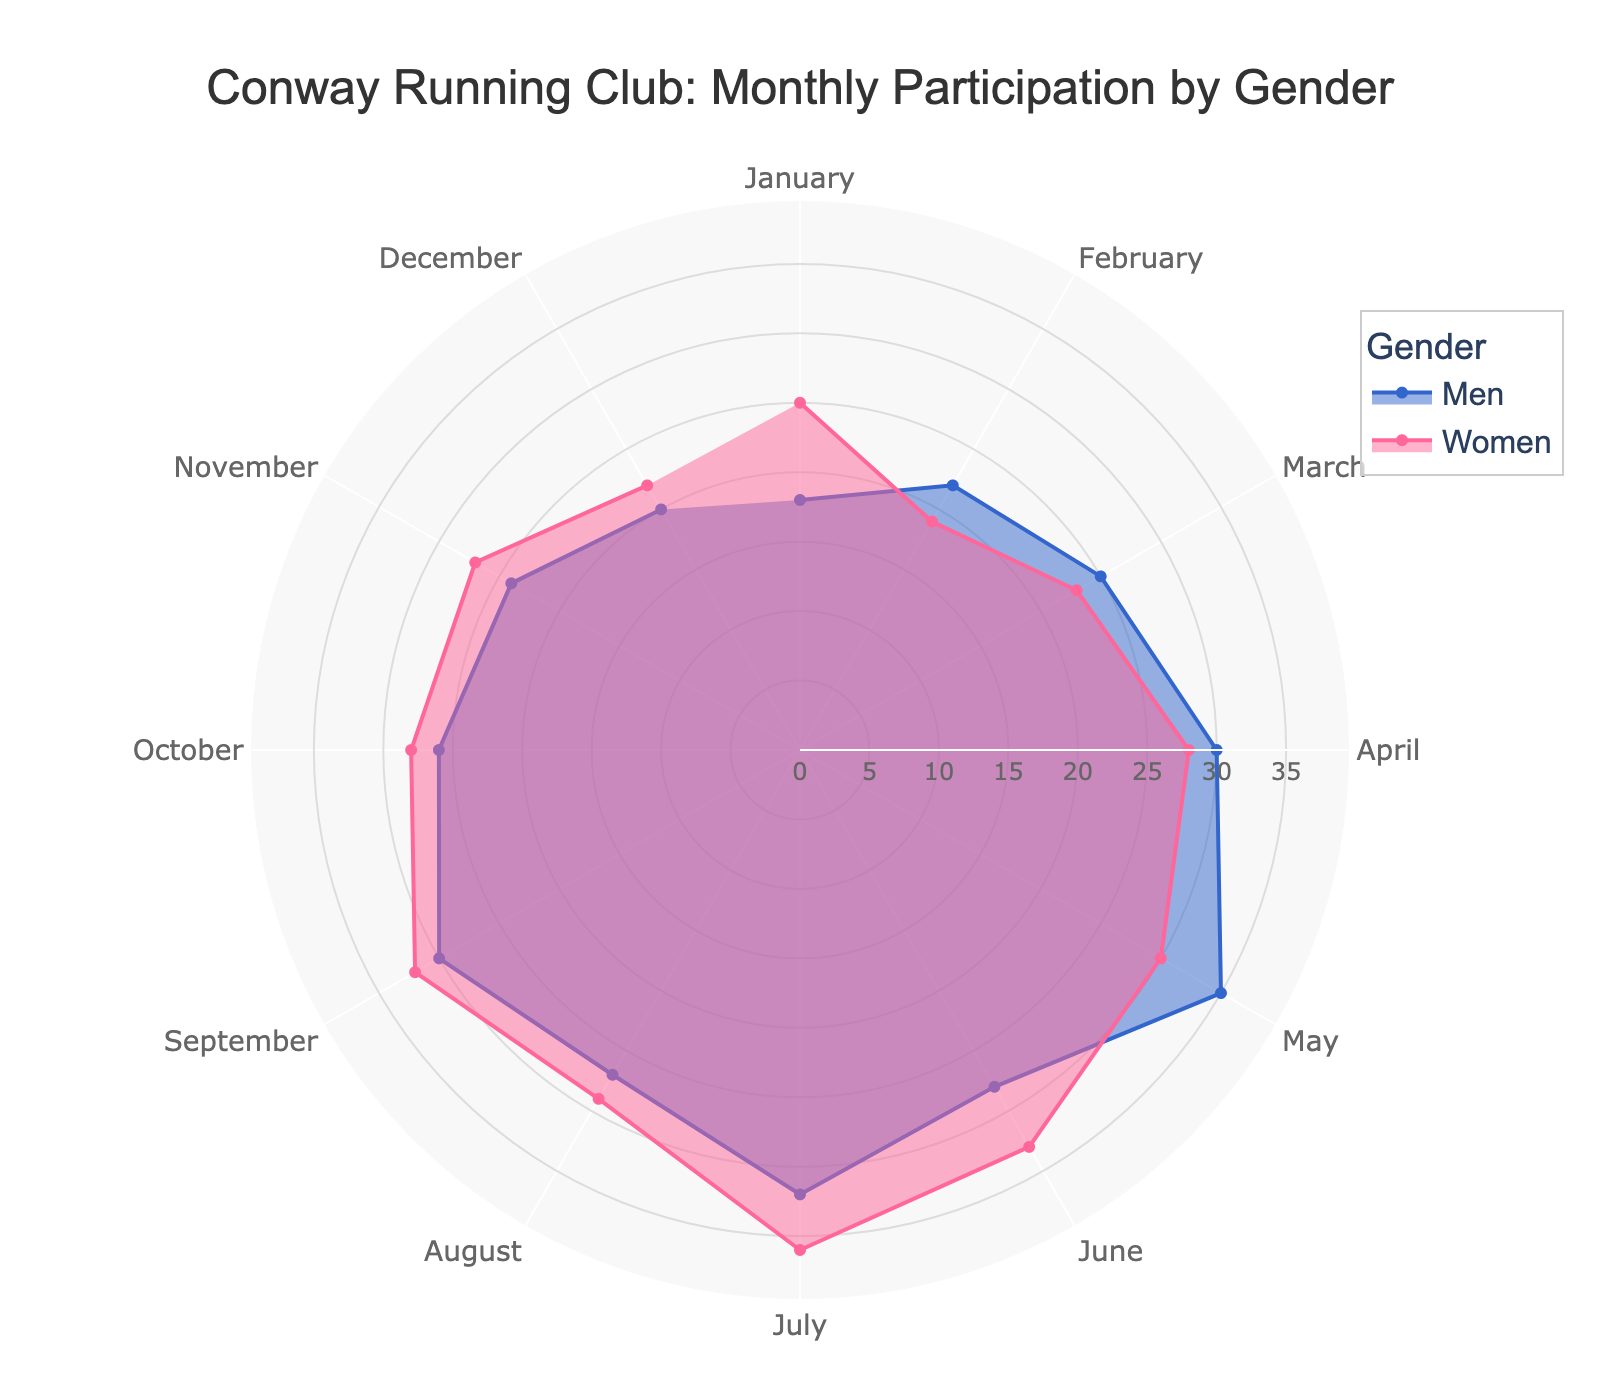What's the title of the chart? The title can be found at the top of the chart.
Answer: Conway Running Club: Monthly Participation by Gender How many months are depicted in the chart? Count the number of segments in the polar chart, representing each month. There are 12 distinct months.
Answer: 12 In which month did men have the highest participation? Look for the month where the blue sector extends the furthest from the center. This is May.
Answer: May How many more participants did women have compared to men in June? Find the radial value for men and women in June, then subtract the men's value from the women's value (33 - 28 = 5).
Answer: 5 Which month had the smallest gender difference in participation rates? Calculate the difference between men's and women's participation for each month and find the smallest difference. The smallest difference is in August, with men at 27 and women at 29 (difference of 2).
Answer: August Which gender had higher participation in most months? Compare the lengths of the sectors for men and women across all months. Women have more sectors extending further out.
Answer: Women Is there any month where the participation rates for men and women are equal? Visually inspect each segment; there are no months where the lengths of the sectors for men and women are the same.
Answer: No What is the total participation for men over the year? Sum the participation rates for men from all months (18+22+25+30+35+28+32+27+30+26+24+20 = 317).
Answer: 317 What is the average monthly participation rate for women? Sum the participation rates for women from all months (25+19+23+28+30+33+36+29+32+28+27+22 = 332) and divide by 12 (332 / 12 ≈ 27.67).
Answer: 27.67 Define two months where the participation rates crossed over (men had higher participation one month and women had higher participation the next month). Look for adjacent months where the relative lengths of the sectors change between genders. This happens between February and March: in February, men (22) are higher than women (19), and in March, women (23) are less than men (25).
Answer: February and March 